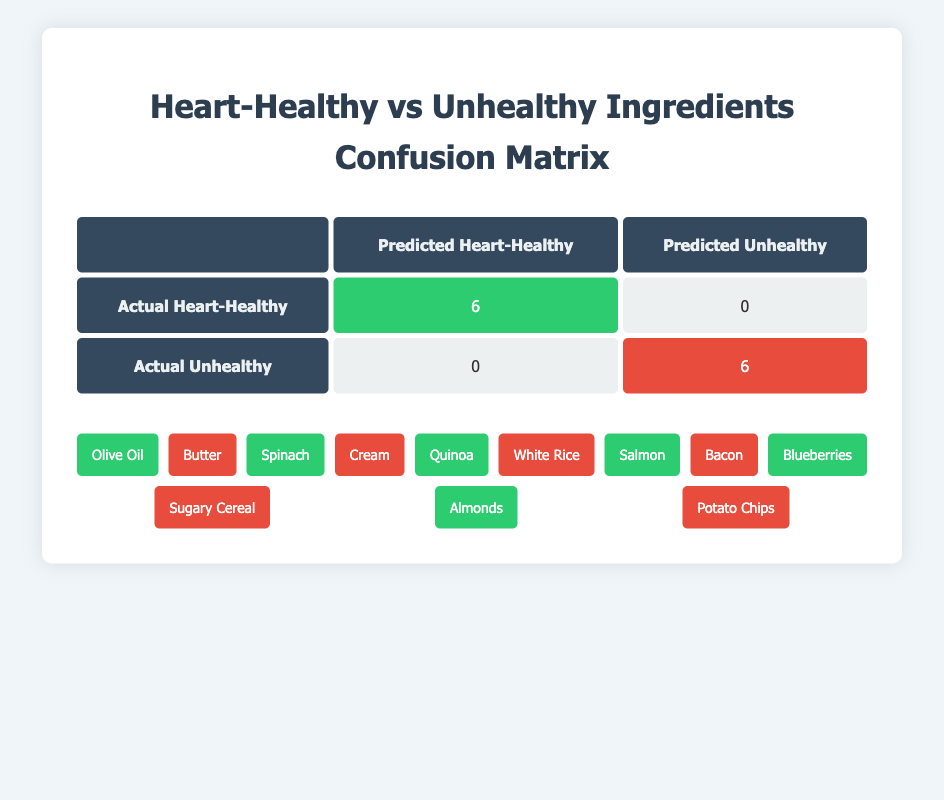What percentage of ingredients are classified as heart-healthy? There are a total of 12 ingredients. Among them, 6 are classified as heart-healthy. To find the percentage, we calculate (6/12)*100, which equals 50%.
Answer: 50% How many ingredients are labeled as unhealthy? The table indicates there are 6 ingredients classified as unhealthy.
Answer: 6 Is it true that all heart-healthy ingredients were predicted correctly? According to the table, there are 6 actual heart-healthy ingredients, and all 6 are predicted as heart-healthy (reported as the diagonal count), indicating that the prediction was entirely accurate.
Answer: Yes If we were to add the actual counts of both heart-healthy and unhealthy ingredients, what would the total be? There are 6 heart-healthy and 6 unhealthy ingredients. Therefore, the total is 6 + 6 = 12.
Answer: 12 Which ingredient group (heart-healthy or unhealthy) has more variety in the types of food listed? Both categories have the same number of ingredients, with 6 each. Therefore, there is no difference in variety since they are equal.
Answer: Neither What is the total number of ingredients that could potentially mislead someone regarding their health impact based on the predictions? Since all heart-healthy ingredients are correctly predicted (0 false negatives), and all unhealthy ingredients are also accurately predicted (0 false positives), there are no misleading predictions. Therefore, the total number is 0.
Answer: 0 What is the ratio of heart-healthy to unhealthy ingredients in the table? There are 6 heart-healthy ingredients and 6 unhealthy ingredients, making the ratio 6:6 or simplified to 1:1.
Answer: 1:1 If you avoided all unhealthy ingredients listed, how many would you be excluding from 12 total ingredients? Since there are 6 unhealthy ingredients, if you avoided all of them, you would be excluding 6 out of the 12 total ingredients.
Answer: 6 What is the total predicted count of both classifications in the confusion matrix? The total predicted count is the sum of heart-healthy (6) and unhealthy (6), resulting in a total of 12 predictions.
Answer: 12 